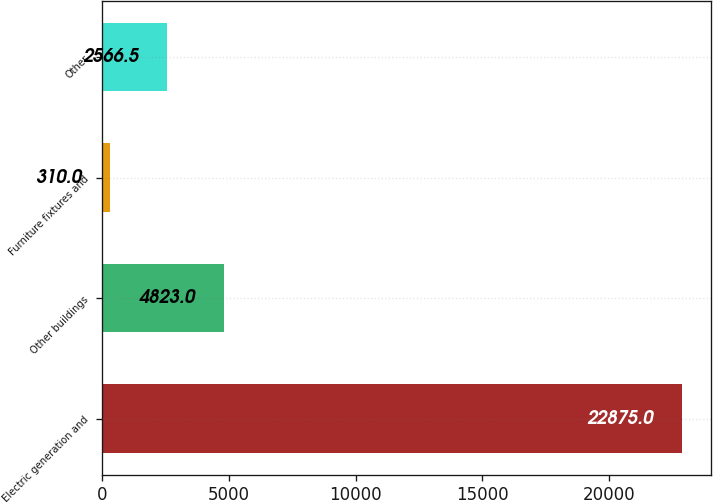Convert chart to OTSL. <chart><loc_0><loc_0><loc_500><loc_500><bar_chart><fcel>Electric generation and<fcel>Other buildings<fcel>Furniture fixtures and<fcel>Other<nl><fcel>22875<fcel>4823<fcel>310<fcel>2566.5<nl></chart> 